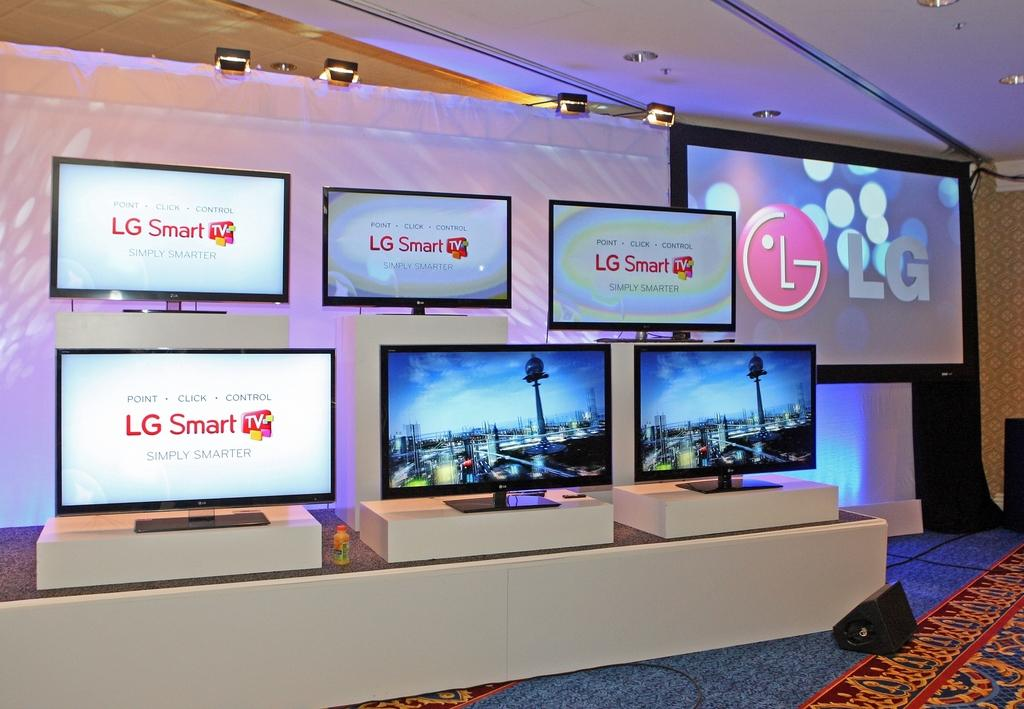<image>
Give a short and clear explanation of the subsequent image. A display of six LG Smart tv's and one large screen LG tv. 